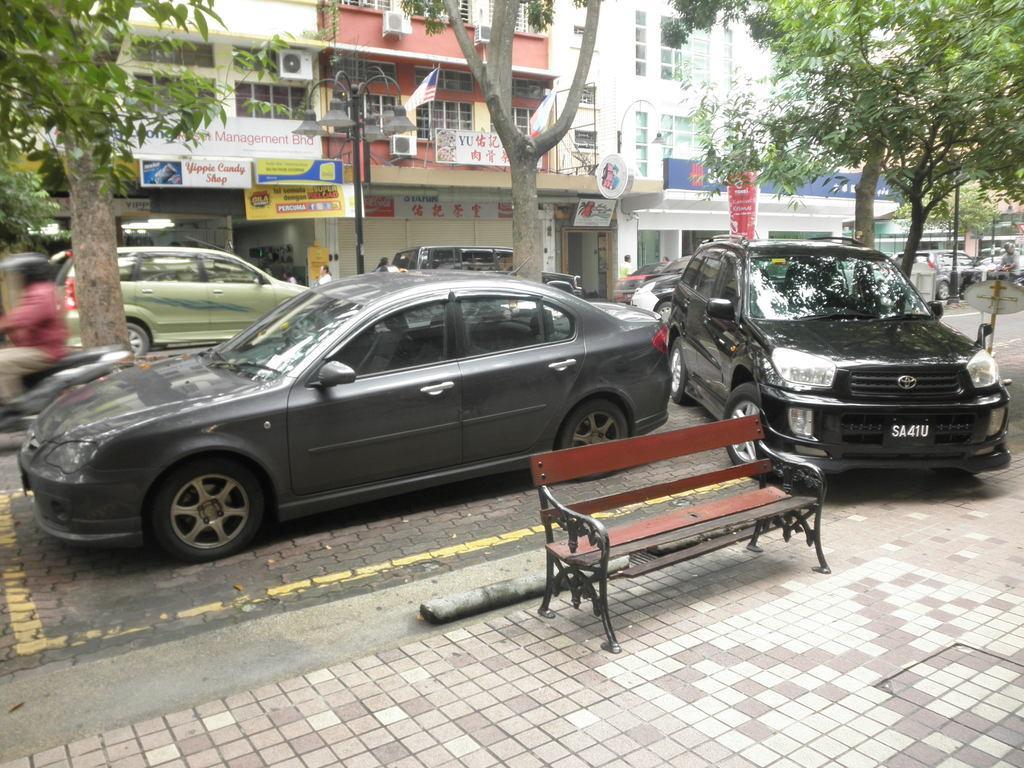What type of structures can be seen in the image? There are buildings in the image. What type of advertisements are present in the image? There are hoardings in the image. What type of establishment can be found in the image? There is a store in the image. What type of vegetation is present in the image? There are trees in the image. What type of transportation is visible on the road in the image? There are vehicles on the road in the image. What activity is the man in the image engaged in? A man is riding a bike in the image. What safety precaution is the man taking while riding the bike? The man is wearing a helmet. What type of seating is available in the image? There is an empty bench in the image. What type of glove is the man wearing while riding the bike in the image? The man is not wearing a glove in the image; he is wearing a helmet. What type of thunder can be heard in the image? There is no thunder present in the image, as it is a visual representation and does not include sound. 